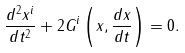<formula> <loc_0><loc_0><loc_500><loc_500>\frac { d ^ { 2 } x ^ { i } } { d t ^ { 2 } } + 2 G ^ { i } \left ( x , \frac { d x } { d t } \right ) = 0 .</formula> 